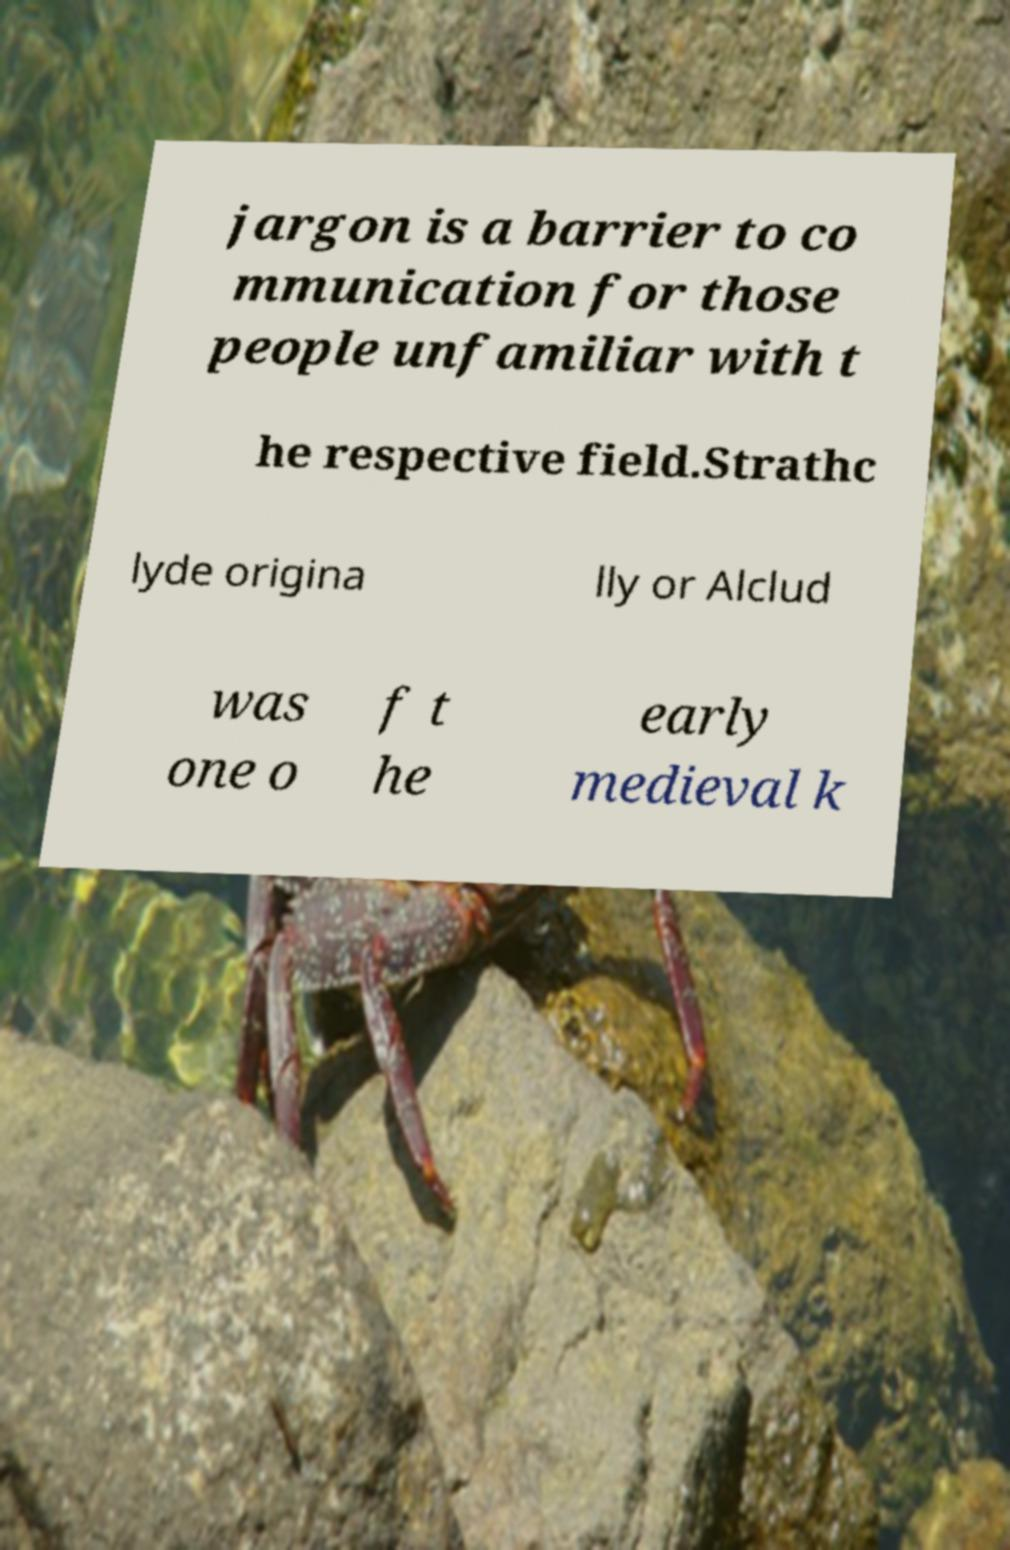Could you extract and type out the text from this image? jargon is a barrier to co mmunication for those people unfamiliar with t he respective field.Strathc lyde origina lly or Alclud was one o f t he early medieval k 